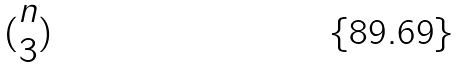<formula> <loc_0><loc_0><loc_500><loc_500>( \begin{matrix} n \\ 3 \end{matrix} )</formula> 